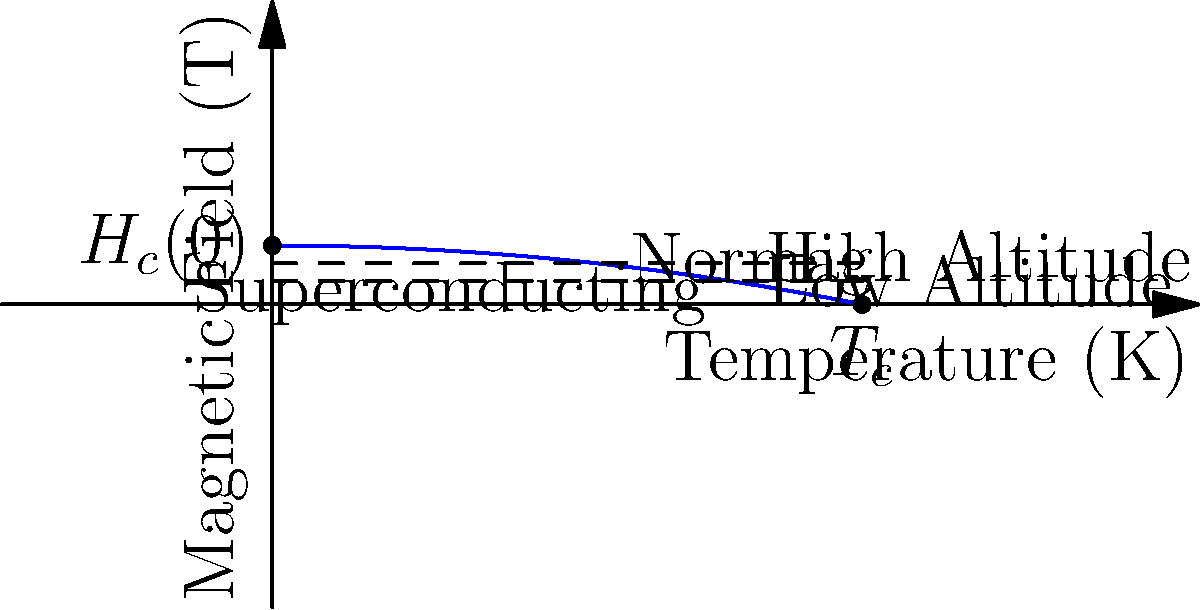Consider the phase diagram of a superconductor shown above, where the blue curve represents the critical field $H_c(T)$ as a function of temperature. The dashed lines indicate different altitude levels. How does the critical temperature $T_c$ of the superconductor change as we move from low to high altitude? Explain your reasoning using the relationship between critical field and altitude. To answer this question, we need to follow these steps:

1) First, recall that the critical field $H_c(T)$ of a superconductor is typically described by the empirical relation:

   $$H_c(T) = H_c(0)[1 - (T/T_c)^2]$$

   where $H_c(0)$ is the critical field at zero temperature and $T_c$ is the critical temperature.

2) From the phase diagram, we can see that the dashed lines representing different altitudes are horizontal, meaning they represent constant magnetic field values.

3) At higher altitudes, the Earth's magnetic field is weaker. This is represented by the upper dashed line in the diagram.

4) For a given temperature, a weaker magnetic field (higher altitude) intersects the phase boundary at a point further to the right compared to a stronger magnetic field (lower altitude).

5) This means that at higher altitudes, the superconductor can remain in the superconducting state at higher temperatures.

6) Therefore, as we move from low to high altitude, the effective critical temperature $T_c$ of the superconductor increases.

7) Physically, this occurs because there's less external magnetic field to suppress the superconductivity at higher altitudes, allowing the material to remain superconducting at higher temperatures.
Answer: $T_c$ increases with altitude 